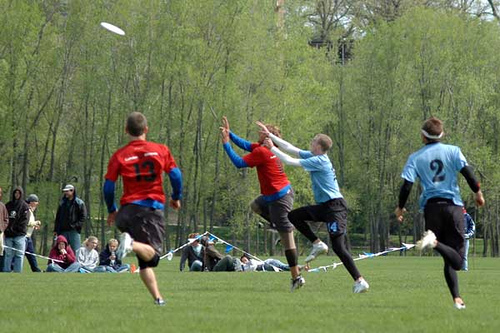How many people are there? There appear to be four people captured in the midst of an exciting outdoor game, possibly frisbee. Each of them is engaged dynamically, suggesting vigorous movement and competitive spirit. 